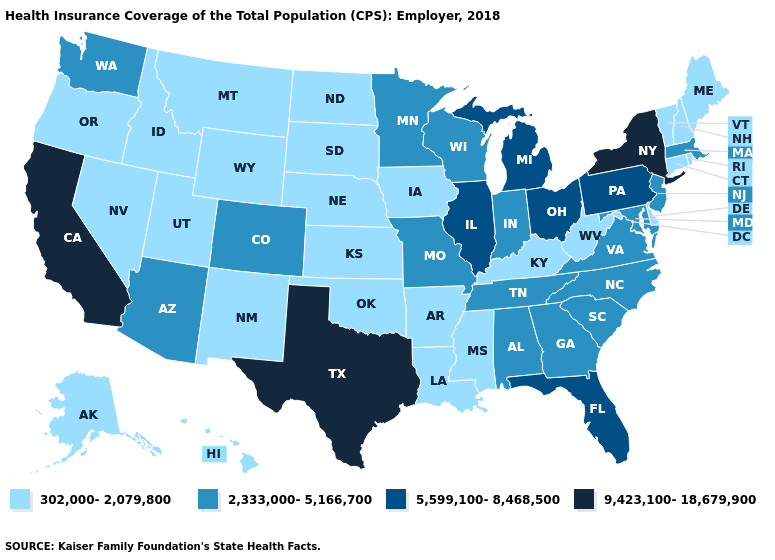What is the lowest value in the MidWest?
Concise answer only. 302,000-2,079,800. Among the states that border Pennsylvania , does Maryland have the highest value?
Write a very short answer. No. Does Iowa have a lower value than Louisiana?
Keep it brief. No. Name the states that have a value in the range 5,599,100-8,468,500?
Concise answer only. Florida, Illinois, Michigan, Ohio, Pennsylvania. Name the states that have a value in the range 302,000-2,079,800?
Concise answer only. Alaska, Arkansas, Connecticut, Delaware, Hawaii, Idaho, Iowa, Kansas, Kentucky, Louisiana, Maine, Mississippi, Montana, Nebraska, Nevada, New Hampshire, New Mexico, North Dakota, Oklahoma, Oregon, Rhode Island, South Dakota, Utah, Vermont, West Virginia, Wyoming. What is the value of Missouri?
Answer briefly. 2,333,000-5,166,700. Among the states that border South Dakota , does Minnesota have the lowest value?
Write a very short answer. No. Among the states that border Alabama , does Florida have the lowest value?
Short answer required. No. Does New York have the lowest value in the Northeast?
Concise answer only. No. Does Idaho have the same value as Alaska?
Quick response, please. Yes. Does Michigan have the highest value in the MidWest?
Be succinct. Yes. Which states have the lowest value in the Northeast?
Be succinct. Connecticut, Maine, New Hampshire, Rhode Island, Vermont. What is the highest value in the USA?
Concise answer only. 9,423,100-18,679,900. Name the states that have a value in the range 5,599,100-8,468,500?
Be succinct. Florida, Illinois, Michigan, Ohio, Pennsylvania. Does Virginia have a higher value than Ohio?
Quick response, please. No. 